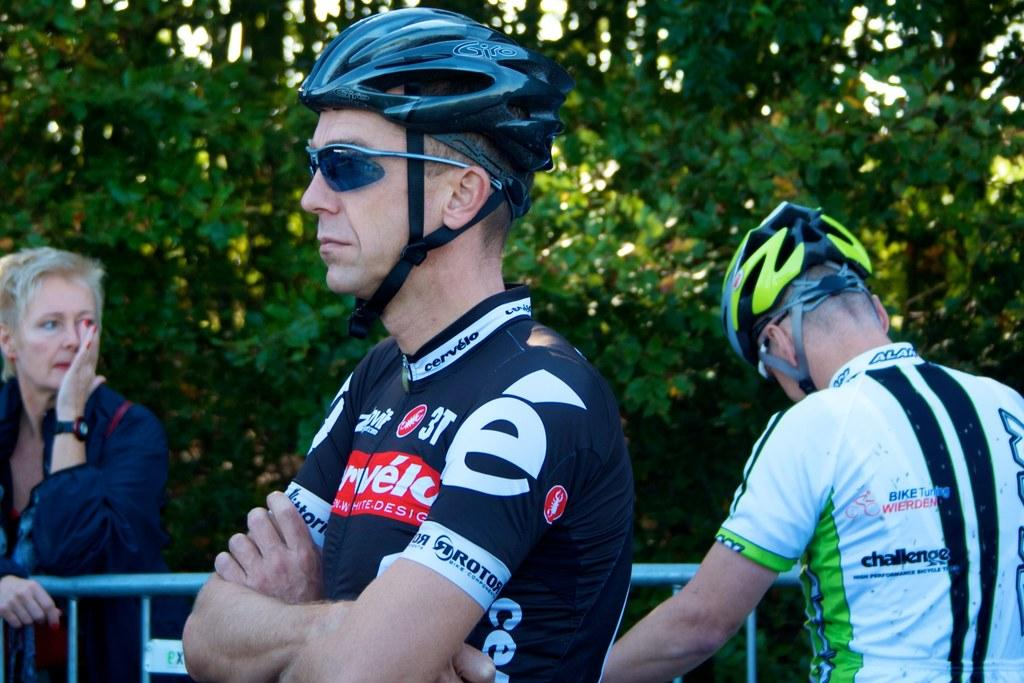How many people are in the image? There are two men and a woman in the image. What are the men wearing? The men are wearing jerseys. What can be seen in the background of the image? There is a fence and trees in the background of the image. Are there any other objects in the image besides the people? Yes, there are other objects in the image. What is the name of the artist who painted the canvas in the image? There is no canvas or artist mentioned in the image. What type of air is visible in the image? There is no air visible in the image, as air is not something that can be seen. 